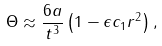<formula> <loc_0><loc_0><loc_500><loc_500>\Theta \approx \frac { 6 a } { t ^ { 3 } } \left ( 1 - \epsilon c _ { 1 } r ^ { 2 } \right ) ,</formula> 